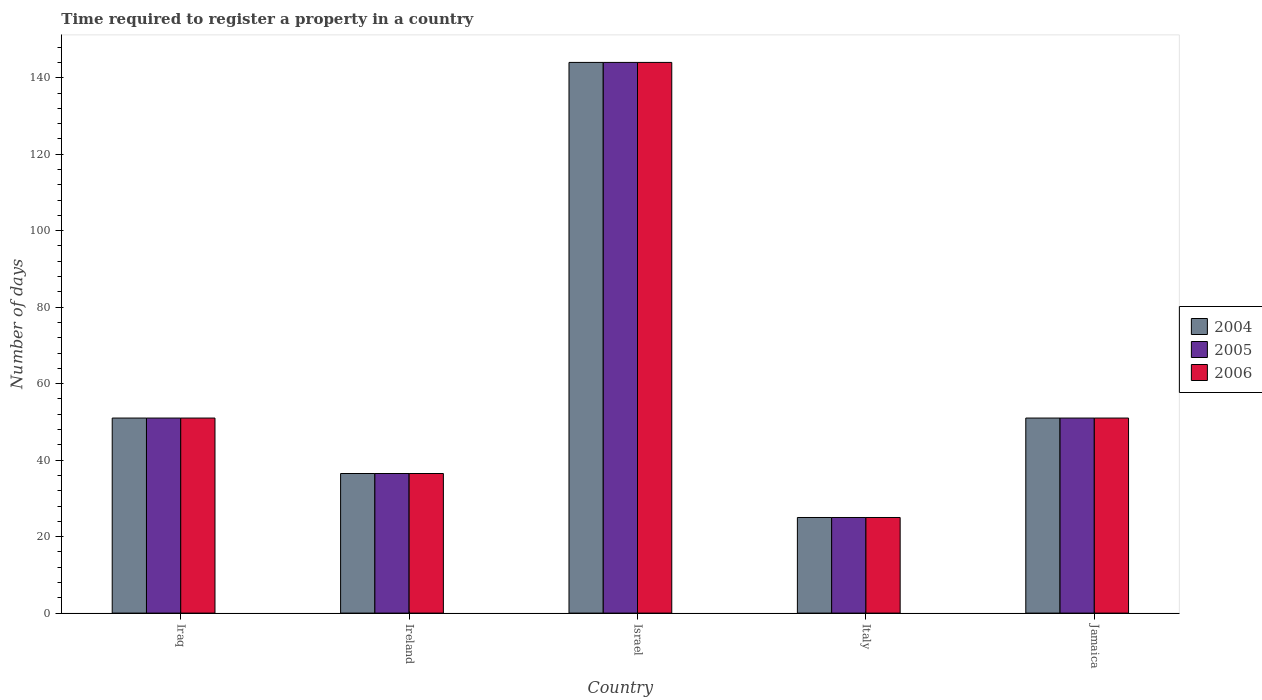How many different coloured bars are there?
Provide a short and direct response. 3. How many groups of bars are there?
Offer a very short reply. 5. Are the number of bars per tick equal to the number of legend labels?
Your answer should be very brief. Yes. Are the number of bars on each tick of the X-axis equal?
Your answer should be compact. Yes. How many bars are there on the 5th tick from the left?
Keep it short and to the point. 3. What is the label of the 2nd group of bars from the left?
Make the answer very short. Ireland. In how many cases, is the number of bars for a given country not equal to the number of legend labels?
Provide a succinct answer. 0. Across all countries, what is the maximum number of days required to register a property in 2006?
Ensure brevity in your answer.  144. Across all countries, what is the minimum number of days required to register a property in 2006?
Your answer should be compact. 25. In which country was the number of days required to register a property in 2004 maximum?
Offer a terse response. Israel. In which country was the number of days required to register a property in 2005 minimum?
Provide a short and direct response. Italy. What is the total number of days required to register a property in 2005 in the graph?
Your response must be concise. 307.5. What is the difference between the number of days required to register a property in 2004 in Israel and that in Italy?
Your answer should be very brief. 119. What is the average number of days required to register a property in 2005 per country?
Provide a short and direct response. 61.5. What is the difference between the number of days required to register a property of/in 2005 and number of days required to register a property of/in 2006 in Ireland?
Provide a succinct answer. 0. What is the ratio of the number of days required to register a property in 2004 in Iraq to that in Israel?
Ensure brevity in your answer.  0.35. Is the number of days required to register a property in 2005 in Israel less than that in Italy?
Your answer should be very brief. No. Is the difference between the number of days required to register a property in 2005 in Italy and Jamaica greater than the difference between the number of days required to register a property in 2006 in Italy and Jamaica?
Offer a very short reply. No. What is the difference between the highest and the second highest number of days required to register a property in 2005?
Your answer should be very brief. 93. What is the difference between the highest and the lowest number of days required to register a property in 2004?
Keep it short and to the point. 119. In how many countries, is the number of days required to register a property in 2005 greater than the average number of days required to register a property in 2005 taken over all countries?
Make the answer very short. 1. Is the sum of the number of days required to register a property in 2005 in Ireland and Italy greater than the maximum number of days required to register a property in 2006 across all countries?
Your answer should be very brief. No. What does the 2nd bar from the left in Israel represents?
Make the answer very short. 2005. What does the 1st bar from the right in Jamaica represents?
Your answer should be very brief. 2006. How many bars are there?
Ensure brevity in your answer.  15. Are all the bars in the graph horizontal?
Offer a terse response. No. How many countries are there in the graph?
Provide a short and direct response. 5. Does the graph contain any zero values?
Provide a succinct answer. No. How are the legend labels stacked?
Make the answer very short. Vertical. What is the title of the graph?
Provide a succinct answer. Time required to register a property in a country. What is the label or title of the X-axis?
Give a very brief answer. Country. What is the label or title of the Y-axis?
Provide a succinct answer. Number of days. What is the Number of days of 2005 in Iraq?
Offer a terse response. 51. What is the Number of days in 2004 in Ireland?
Your answer should be very brief. 36.5. What is the Number of days in 2005 in Ireland?
Offer a terse response. 36.5. What is the Number of days in 2006 in Ireland?
Offer a very short reply. 36.5. What is the Number of days in 2004 in Israel?
Give a very brief answer. 144. What is the Number of days of 2005 in Israel?
Keep it short and to the point. 144. What is the Number of days of 2006 in Israel?
Ensure brevity in your answer.  144. What is the Number of days in 2004 in Italy?
Keep it short and to the point. 25. What is the Number of days in 2004 in Jamaica?
Make the answer very short. 51. Across all countries, what is the maximum Number of days of 2004?
Make the answer very short. 144. Across all countries, what is the maximum Number of days in 2005?
Your answer should be compact. 144. Across all countries, what is the maximum Number of days of 2006?
Offer a terse response. 144. Across all countries, what is the minimum Number of days in 2005?
Ensure brevity in your answer.  25. Across all countries, what is the minimum Number of days in 2006?
Your answer should be compact. 25. What is the total Number of days in 2004 in the graph?
Offer a terse response. 307.5. What is the total Number of days of 2005 in the graph?
Offer a terse response. 307.5. What is the total Number of days in 2006 in the graph?
Your answer should be very brief. 307.5. What is the difference between the Number of days in 2004 in Iraq and that in Israel?
Provide a succinct answer. -93. What is the difference between the Number of days of 2005 in Iraq and that in Israel?
Give a very brief answer. -93. What is the difference between the Number of days in 2006 in Iraq and that in Israel?
Your answer should be compact. -93. What is the difference between the Number of days of 2004 in Iraq and that in Italy?
Ensure brevity in your answer.  26. What is the difference between the Number of days of 2005 in Iraq and that in Italy?
Offer a terse response. 26. What is the difference between the Number of days of 2004 in Iraq and that in Jamaica?
Offer a terse response. 0. What is the difference between the Number of days of 2006 in Iraq and that in Jamaica?
Ensure brevity in your answer.  0. What is the difference between the Number of days of 2004 in Ireland and that in Israel?
Provide a succinct answer. -107.5. What is the difference between the Number of days of 2005 in Ireland and that in Israel?
Your answer should be very brief. -107.5. What is the difference between the Number of days of 2006 in Ireland and that in Israel?
Ensure brevity in your answer.  -107.5. What is the difference between the Number of days of 2004 in Ireland and that in Italy?
Make the answer very short. 11.5. What is the difference between the Number of days in 2004 in Ireland and that in Jamaica?
Make the answer very short. -14.5. What is the difference between the Number of days of 2004 in Israel and that in Italy?
Your answer should be very brief. 119. What is the difference between the Number of days in 2005 in Israel and that in Italy?
Keep it short and to the point. 119. What is the difference between the Number of days in 2006 in Israel and that in Italy?
Make the answer very short. 119. What is the difference between the Number of days in 2004 in Israel and that in Jamaica?
Ensure brevity in your answer.  93. What is the difference between the Number of days of 2005 in Israel and that in Jamaica?
Give a very brief answer. 93. What is the difference between the Number of days in 2006 in Israel and that in Jamaica?
Keep it short and to the point. 93. What is the difference between the Number of days of 2004 in Italy and that in Jamaica?
Offer a terse response. -26. What is the difference between the Number of days in 2004 in Iraq and the Number of days in 2005 in Ireland?
Keep it short and to the point. 14.5. What is the difference between the Number of days of 2005 in Iraq and the Number of days of 2006 in Ireland?
Your answer should be compact. 14.5. What is the difference between the Number of days of 2004 in Iraq and the Number of days of 2005 in Israel?
Ensure brevity in your answer.  -93. What is the difference between the Number of days of 2004 in Iraq and the Number of days of 2006 in Israel?
Provide a short and direct response. -93. What is the difference between the Number of days of 2005 in Iraq and the Number of days of 2006 in Israel?
Your response must be concise. -93. What is the difference between the Number of days of 2004 in Iraq and the Number of days of 2006 in Jamaica?
Give a very brief answer. 0. What is the difference between the Number of days of 2005 in Iraq and the Number of days of 2006 in Jamaica?
Your answer should be very brief. 0. What is the difference between the Number of days in 2004 in Ireland and the Number of days in 2005 in Israel?
Provide a short and direct response. -107.5. What is the difference between the Number of days of 2004 in Ireland and the Number of days of 2006 in Israel?
Provide a short and direct response. -107.5. What is the difference between the Number of days in 2005 in Ireland and the Number of days in 2006 in Israel?
Provide a succinct answer. -107.5. What is the difference between the Number of days of 2004 in Ireland and the Number of days of 2005 in Italy?
Your response must be concise. 11.5. What is the difference between the Number of days of 2004 in Ireland and the Number of days of 2006 in Italy?
Give a very brief answer. 11.5. What is the difference between the Number of days in 2004 in Ireland and the Number of days in 2006 in Jamaica?
Provide a succinct answer. -14.5. What is the difference between the Number of days in 2004 in Israel and the Number of days in 2005 in Italy?
Keep it short and to the point. 119. What is the difference between the Number of days of 2004 in Israel and the Number of days of 2006 in Italy?
Offer a terse response. 119. What is the difference between the Number of days of 2005 in Israel and the Number of days of 2006 in Italy?
Provide a succinct answer. 119. What is the difference between the Number of days in 2004 in Israel and the Number of days in 2005 in Jamaica?
Provide a succinct answer. 93. What is the difference between the Number of days of 2004 in Israel and the Number of days of 2006 in Jamaica?
Your answer should be very brief. 93. What is the difference between the Number of days of 2005 in Israel and the Number of days of 2006 in Jamaica?
Keep it short and to the point. 93. What is the difference between the Number of days of 2004 in Italy and the Number of days of 2005 in Jamaica?
Keep it short and to the point. -26. What is the average Number of days in 2004 per country?
Ensure brevity in your answer.  61.5. What is the average Number of days in 2005 per country?
Your answer should be very brief. 61.5. What is the average Number of days in 2006 per country?
Ensure brevity in your answer.  61.5. What is the difference between the Number of days in 2004 and Number of days in 2006 in Iraq?
Keep it short and to the point. 0. What is the difference between the Number of days in 2005 and Number of days in 2006 in Iraq?
Provide a succinct answer. 0. What is the difference between the Number of days in 2004 and Number of days in 2005 in Ireland?
Give a very brief answer. 0. What is the difference between the Number of days in 2005 and Number of days in 2006 in Ireland?
Offer a terse response. 0. What is the difference between the Number of days of 2004 and Number of days of 2006 in Israel?
Offer a terse response. 0. What is the difference between the Number of days in 2005 and Number of days in 2006 in Israel?
Your answer should be very brief. 0. What is the difference between the Number of days of 2005 and Number of days of 2006 in Jamaica?
Your response must be concise. 0. What is the ratio of the Number of days in 2004 in Iraq to that in Ireland?
Provide a short and direct response. 1.4. What is the ratio of the Number of days of 2005 in Iraq to that in Ireland?
Your answer should be compact. 1.4. What is the ratio of the Number of days in 2006 in Iraq to that in Ireland?
Provide a short and direct response. 1.4. What is the ratio of the Number of days in 2004 in Iraq to that in Israel?
Your response must be concise. 0.35. What is the ratio of the Number of days in 2005 in Iraq to that in Israel?
Make the answer very short. 0.35. What is the ratio of the Number of days of 2006 in Iraq to that in Israel?
Offer a terse response. 0.35. What is the ratio of the Number of days of 2004 in Iraq to that in Italy?
Provide a succinct answer. 2.04. What is the ratio of the Number of days in 2005 in Iraq to that in Italy?
Your answer should be very brief. 2.04. What is the ratio of the Number of days in 2006 in Iraq to that in Italy?
Your answer should be very brief. 2.04. What is the ratio of the Number of days of 2005 in Iraq to that in Jamaica?
Offer a very short reply. 1. What is the ratio of the Number of days of 2006 in Iraq to that in Jamaica?
Provide a succinct answer. 1. What is the ratio of the Number of days in 2004 in Ireland to that in Israel?
Provide a succinct answer. 0.25. What is the ratio of the Number of days in 2005 in Ireland to that in Israel?
Offer a very short reply. 0.25. What is the ratio of the Number of days of 2006 in Ireland to that in Israel?
Your response must be concise. 0.25. What is the ratio of the Number of days of 2004 in Ireland to that in Italy?
Your response must be concise. 1.46. What is the ratio of the Number of days of 2005 in Ireland to that in Italy?
Your response must be concise. 1.46. What is the ratio of the Number of days of 2006 in Ireland to that in Italy?
Provide a succinct answer. 1.46. What is the ratio of the Number of days in 2004 in Ireland to that in Jamaica?
Provide a short and direct response. 0.72. What is the ratio of the Number of days in 2005 in Ireland to that in Jamaica?
Make the answer very short. 0.72. What is the ratio of the Number of days in 2006 in Ireland to that in Jamaica?
Offer a terse response. 0.72. What is the ratio of the Number of days in 2004 in Israel to that in Italy?
Offer a very short reply. 5.76. What is the ratio of the Number of days in 2005 in Israel to that in Italy?
Ensure brevity in your answer.  5.76. What is the ratio of the Number of days in 2006 in Israel to that in Italy?
Provide a short and direct response. 5.76. What is the ratio of the Number of days in 2004 in Israel to that in Jamaica?
Make the answer very short. 2.82. What is the ratio of the Number of days in 2005 in Israel to that in Jamaica?
Your response must be concise. 2.82. What is the ratio of the Number of days in 2006 in Israel to that in Jamaica?
Provide a short and direct response. 2.82. What is the ratio of the Number of days of 2004 in Italy to that in Jamaica?
Your answer should be compact. 0.49. What is the ratio of the Number of days of 2005 in Italy to that in Jamaica?
Provide a short and direct response. 0.49. What is the ratio of the Number of days of 2006 in Italy to that in Jamaica?
Keep it short and to the point. 0.49. What is the difference between the highest and the second highest Number of days in 2004?
Offer a terse response. 93. What is the difference between the highest and the second highest Number of days of 2005?
Offer a terse response. 93. What is the difference between the highest and the second highest Number of days of 2006?
Your response must be concise. 93. What is the difference between the highest and the lowest Number of days of 2004?
Ensure brevity in your answer.  119. What is the difference between the highest and the lowest Number of days in 2005?
Give a very brief answer. 119. What is the difference between the highest and the lowest Number of days in 2006?
Keep it short and to the point. 119. 